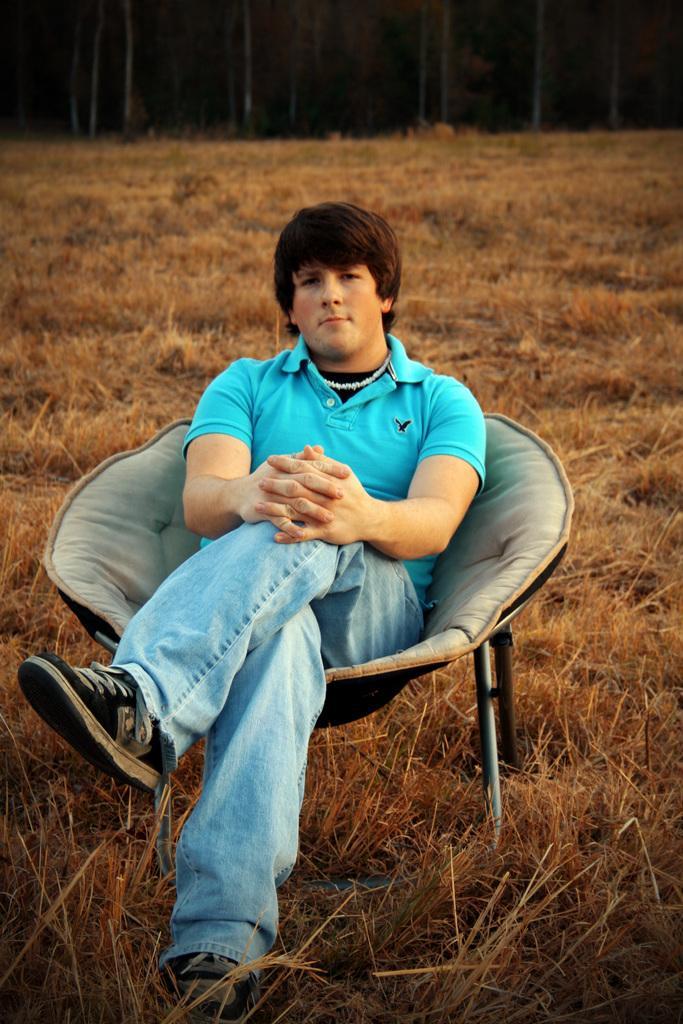How would you summarize this image in a sentence or two? In this image I can see a person sitting and the person is wearing blue shirt and blue pant. Background I can see the dried grass in brown color. 